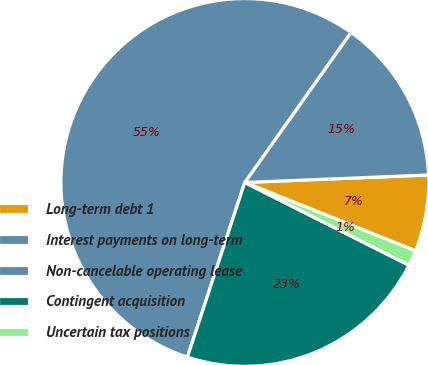<chart> <loc_0><loc_0><loc_500><loc_500><pie_chart><fcel>Long-term debt 1<fcel>Interest payments on long-term<fcel>Non-cancelable operating lease<fcel>Contingent acquisition<fcel>Uncertain tax positions<nl><fcel>6.71%<fcel>14.55%<fcel>54.75%<fcel>22.62%<fcel>1.37%<nl></chart> 